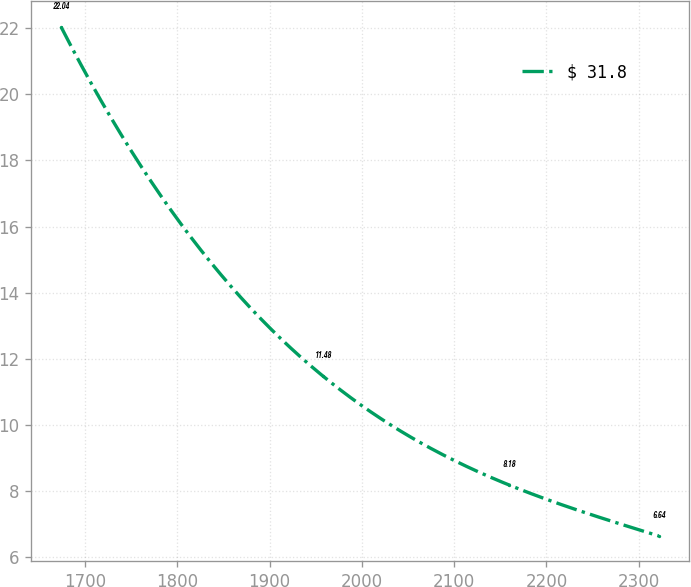<chart> <loc_0><loc_0><loc_500><loc_500><line_chart><ecel><fcel>$ 31.8<nl><fcel>1673.96<fcel>22.04<nl><fcel>1957.59<fcel>11.48<nl><fcel>2159.54<fcel>8.18<nl><fcel>2321.57<fcel>6.64<nl></chart> 